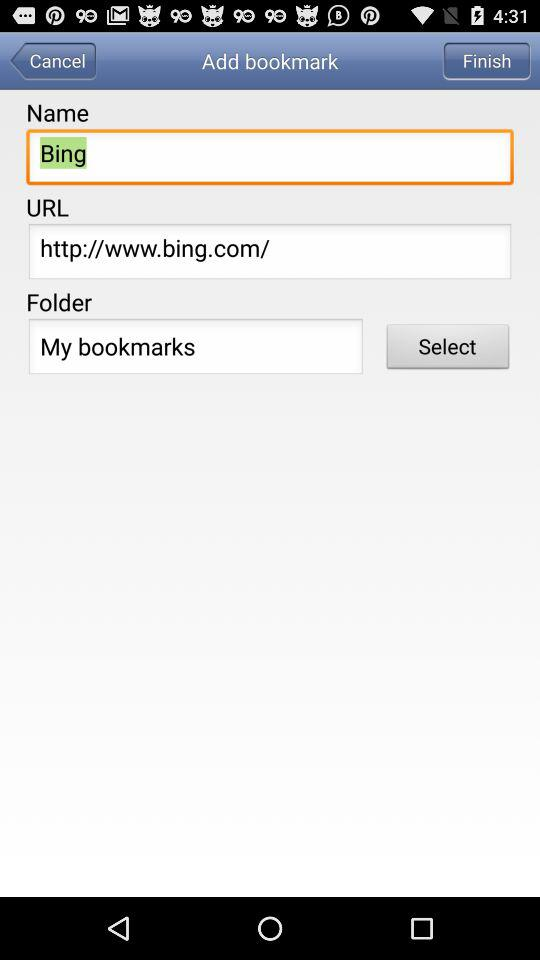What is the folder name given? The folder name is "My bookmarks". 